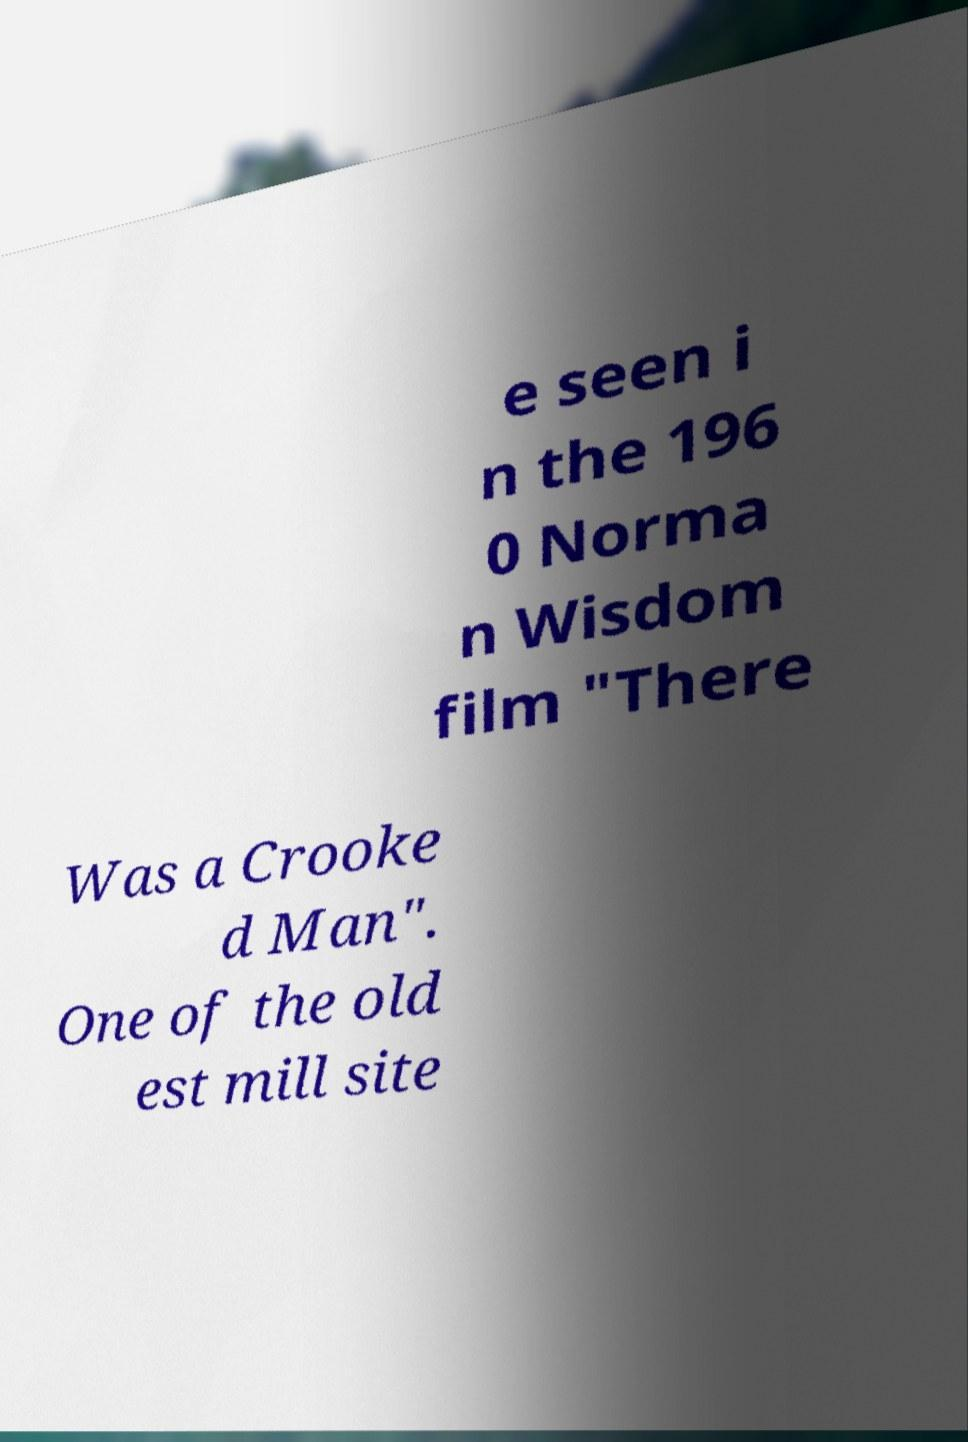Can you read and provide the text displayed in the image?This photo seems to have some interesting text. Can you extract and type it out for me? e seen i n the 196 0 Norma n Wisdom film "There Was a Crooke d Man". One of the old est mill site 